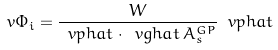Convert formula to latex. <formula><loc_0><loc_0><loc_500><loc_500>\ v { \Phi _ { i } } = \frac { W } { \ v p h a t \cdot \ v g h a t \, A _ { s } ^ { G P } } \ v p h a t \\</formula> 